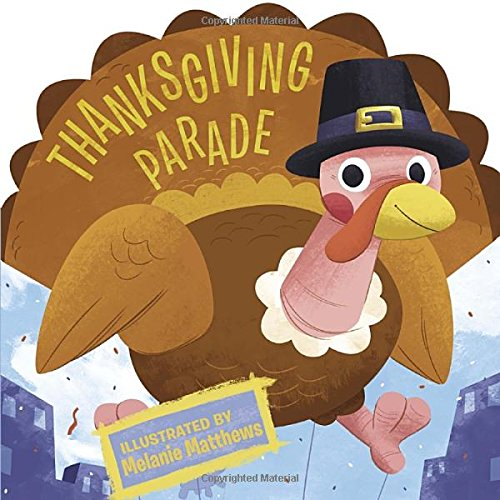What is the title of this book? The title of this charming book is 'Thanksgiving Parade,' which falls under the category of Thanksgiving Board Books. 